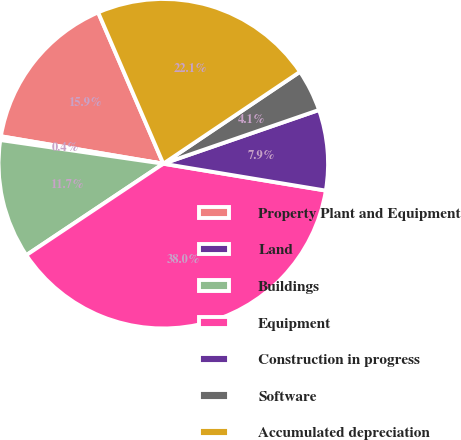<chart> <loc_0><loc_0><loc_500><loc_500><pie_chart><fcel>Property Plant and Equipment<fcel>Land<fcel>Buildings<fcel>Equipment<fcel>Construction in progress<fcel>Software<fcel>Accumulated depreciation<nl><fcel>15.86%<fcel>0.37%<fcel>11.66%<fcel>38.02%<fcel>7.9%<fcel>4.13%<fcel>22.05%<nl></chart> 